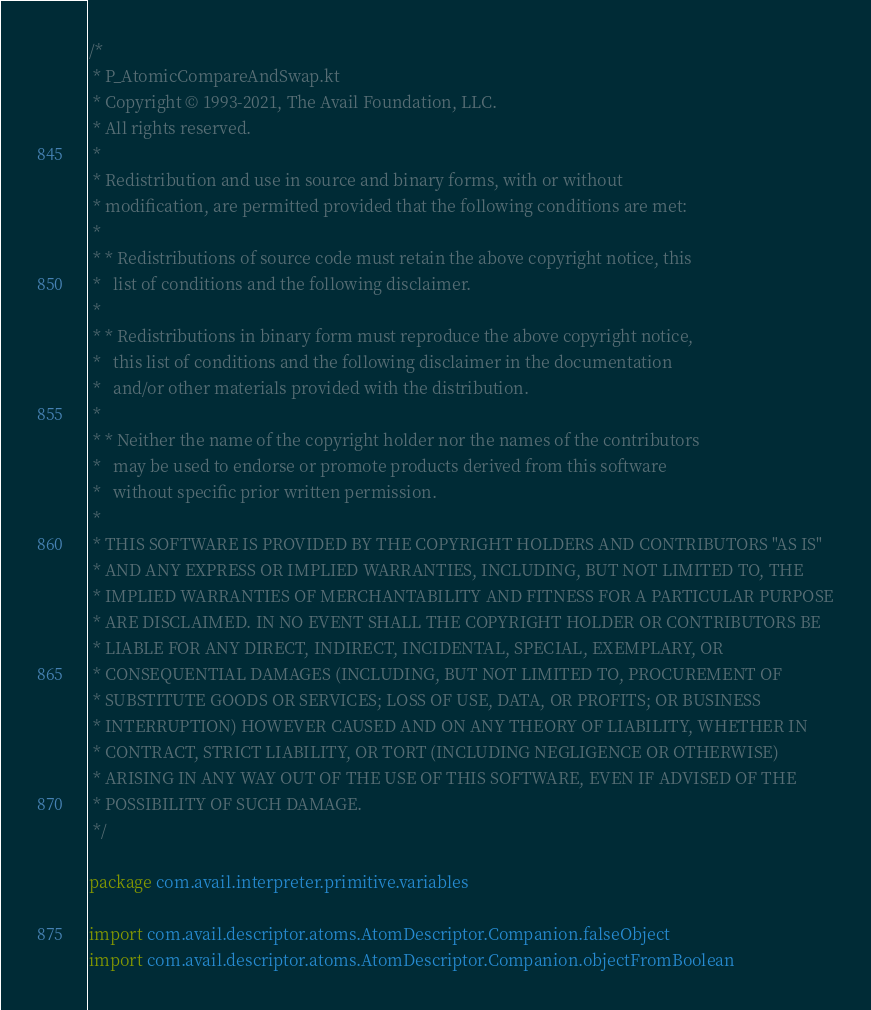Convert code to text. <code><loc_0><loc_0><loc_500><loc_500><_Kotlin_>/*
 * P_AtomicCompareAndSwap.kt
 * Copyright © 1993-2021, The Avail Foundation, LLC.
 * All rights reserved.
 *
 * Redistribution and use in source and binary forms, with or without
 * modification, are permitted provided that the following conditions are met:
 *
 * * Redistributions of source code must retain the above copyright notice, this
 *   list of conditions and the following disclaimer.
 *
 * * Redistributions in binary form must reproduce the above copyright notice,
 *   this list of conditions and the following disclaimer in the documentation
 *   and/or other materials provided with the distribution.
 *
 * * Neither the name of the copyright holder nor the names of the contributors
 *   may be used to endorse or promote products derived from this software
 *   without specific prior written permission.
 *
 * THIS SOFTWARE IS PROVIDED BY THE COPYRIGHT HOLDERS AND CONTRIBUTORS "AS IS"
 * AND ANY EXPRESS OR IMPLIED WARRANTIES, INCLUDING, BUT NOT LIMITED TO, THE
 * IMPLIED WARRANTIES OF MERCHANTABILITY AND FITNESS FOR A PARTICULAR PURPOSE
 * ARE DISCLAIMED. IN NO EVENT SHALL THE COPYRIGHT HOLDER OR CONTRIBUTORS BE
 * LIABLE FOR ANY DIRECT, INDIRECT, INCIDENTAL, SPECIAL, EXEMPLARY, OR
 * CONSEQUENTIAL DAMAGES (INCLUDING, BUT NOT LIMITED TO, PROCUREMENT OF
 * SUBSTITUTE GOODS OR SERVICES; LOSS OF USE, DATA, OR PROFITS; OR BUSINESS
 * INTERRUPTION) HOWEVER CAUSED AND ON ANY THEORY OF LIABILITY, WHETHER IN
 * CONTRACT, STRICT LIABILITY, OR TORT (INCLUDING NEGLIGENCE OR OTHERWISE)
 * ARISING IN ANY WAY OUT OF THE USE OF THIS SOFTWARE, EVEN IF ADVISED OF THE
 * POSSIBILITY OF SUCH DAMAGE.
 */

package com.avail.interpreter.primitive.variables

import com.avail.descriptor.atoms.AtomDescriptor.Companion.falseObject
import com.avail.descriptor.atoms.AtomDescriptor.Companion.objectFromBoolean</code> 